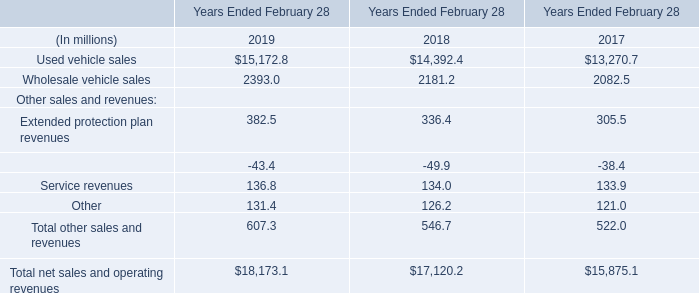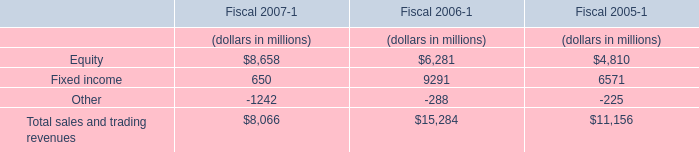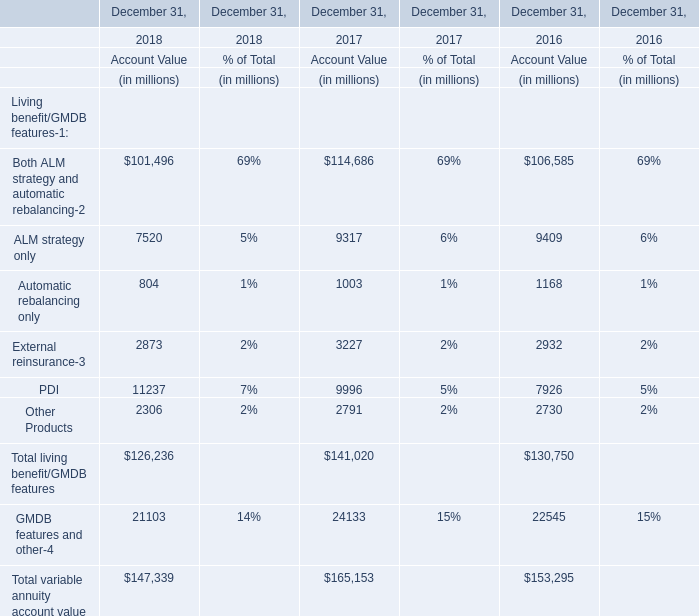What will the Account Value of Other Products on December 31 be like in 2019 if it develops with the same growing rate as current? (in million) 
Computations: (2306 * (1 + ((2306 - 2791) / 2791)))
Answer: 1905.27983. 